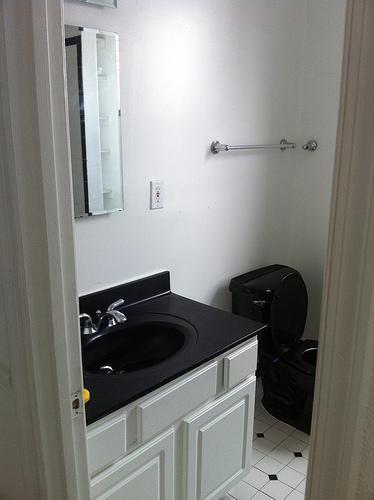How many sinks are in the bathroom?
Give a very brief answer. 1. 